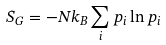<formula> <loc_0><loc_0><loc_500><loc_500>S _ { G } = - N k _ { B } \sum _ { i } p _ { i } \ln p _ { i }</formula> 